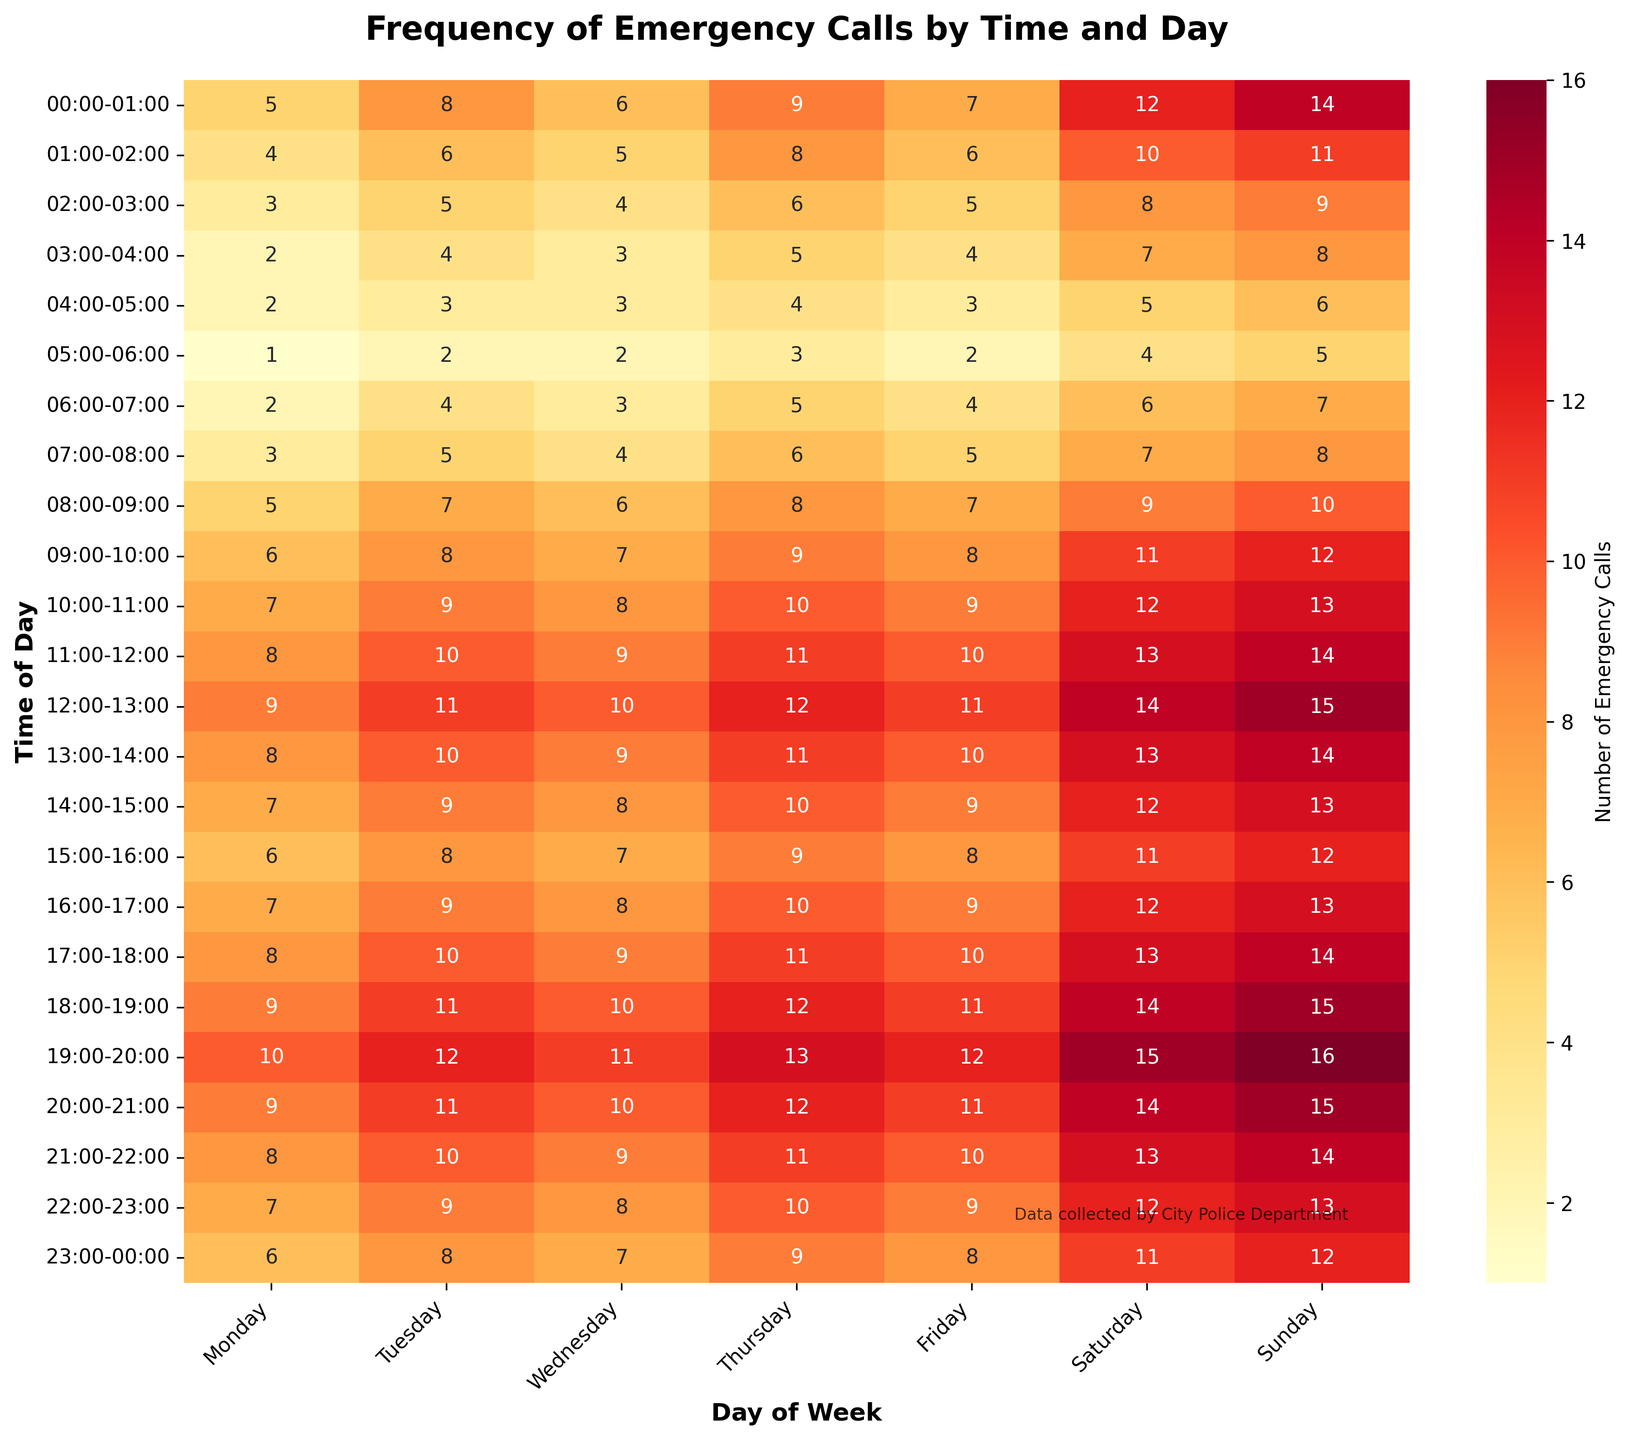What is the title of the heatmap? The title is usually located above the heatmap and provides an overview of what the heatmap represents. In this case, it is "Frequency of Emergency Calls by Time and Day."
Answer: Frequency of Emergency Calls by Time and Day Which hour has the highest number of emergency calls on Saturday? Find the column labeled "Saturday." Then, look for the highest value within that column. According to the given data, the highest value for Saturday is 15, which occurs at 19:00-20:00 and 18:00-19:00.
Answer: 19:00-20:00 and 18:00-19:00 What is the total number of emergency calls on Wednesday? Sum the values in the column labeled "Wednesday." The values are 6+5+4+3+3+2+3+4+6+7+8+9+10+9+8+7+8+9+10+9+8+7=145.
Answer: 145 How does the number of calls change throughout the day on Monday? Look at the "Monday" column to observe the pattern. The number of calls starts low in the early hours, gradually increases during the day, reaching a peak in the early afternoon, and then slightly decreases towards the late evening.
Answer: Starts low, peaks in early afternoon, slight decline in evening Which time slot has the least emergency calls on Tuesday? Look at the column labeled "Tuesday" and find the smallest value. The smallest value is 2, which occurs at 05:00-06:00.
Answer: 05:00-06:00 Is there a significant difference in call frequency between weekdays and weekends? Observe the columns for weekdays (Monday to Friday) and compare them to the weekend columns (Saturday and Sunday). The weekend columns generally have higher values throughout the day, indicating more frequent calls on weekends.
Answer: Yes, more calls on weekends At what times are emergency calls most frequent on Sundays? Identify the highest values in the "Sunday" column. The values 16 occur at both 19:00-20:00 and 20:00-21:00.
Answer: 19:00-20:00 and 20:00-21:00 What is the average number of calls between 00:00 and 04:00 across all days of the week? Sum the values for each day from the 00:00-01:00 to the 03:00-04:00 time slots and divide by the number of slots (4). The sum is (5+8+6+9+7+12+14) + (4+6+5+8+6+10+11) + (3+5+4+6+5+8+9) + (2+4+3+5+4+7+8) = 186. The average is 186/4 = 46.5.
Answer: 46.5 